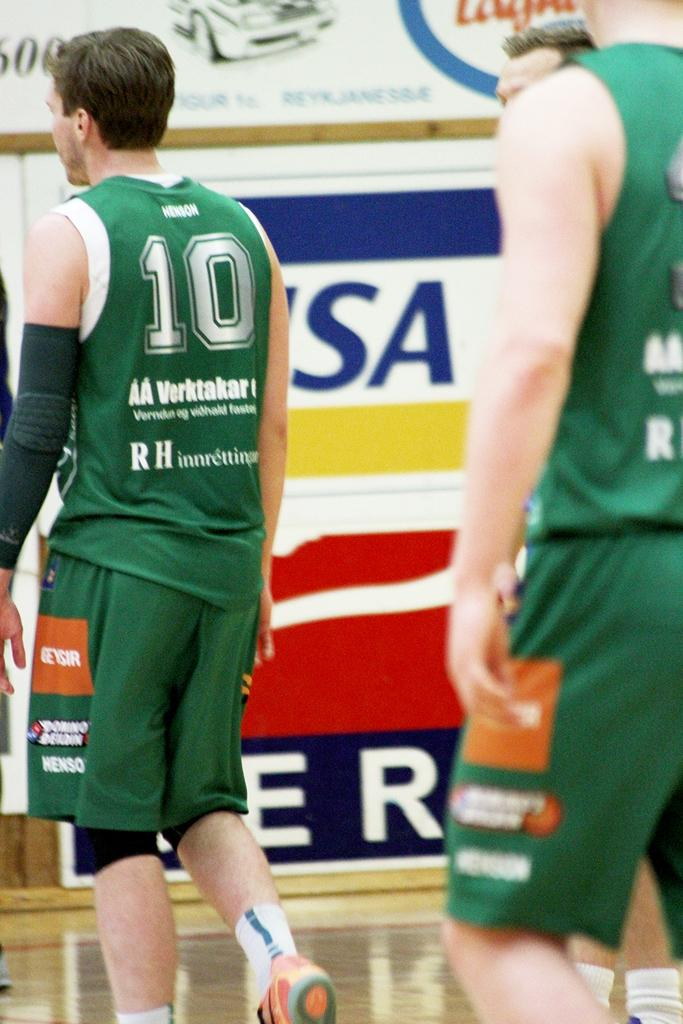Where are the sportsmen located in the image? There are sportsmen on both the right and left sides of the image. What can be seen in the background of the image? There are posters in the background of the image. What type of cap is the teacher wearing in the image? There is no teacher or cap present in the image; it features sportsmen on both sides and posters in the background. 